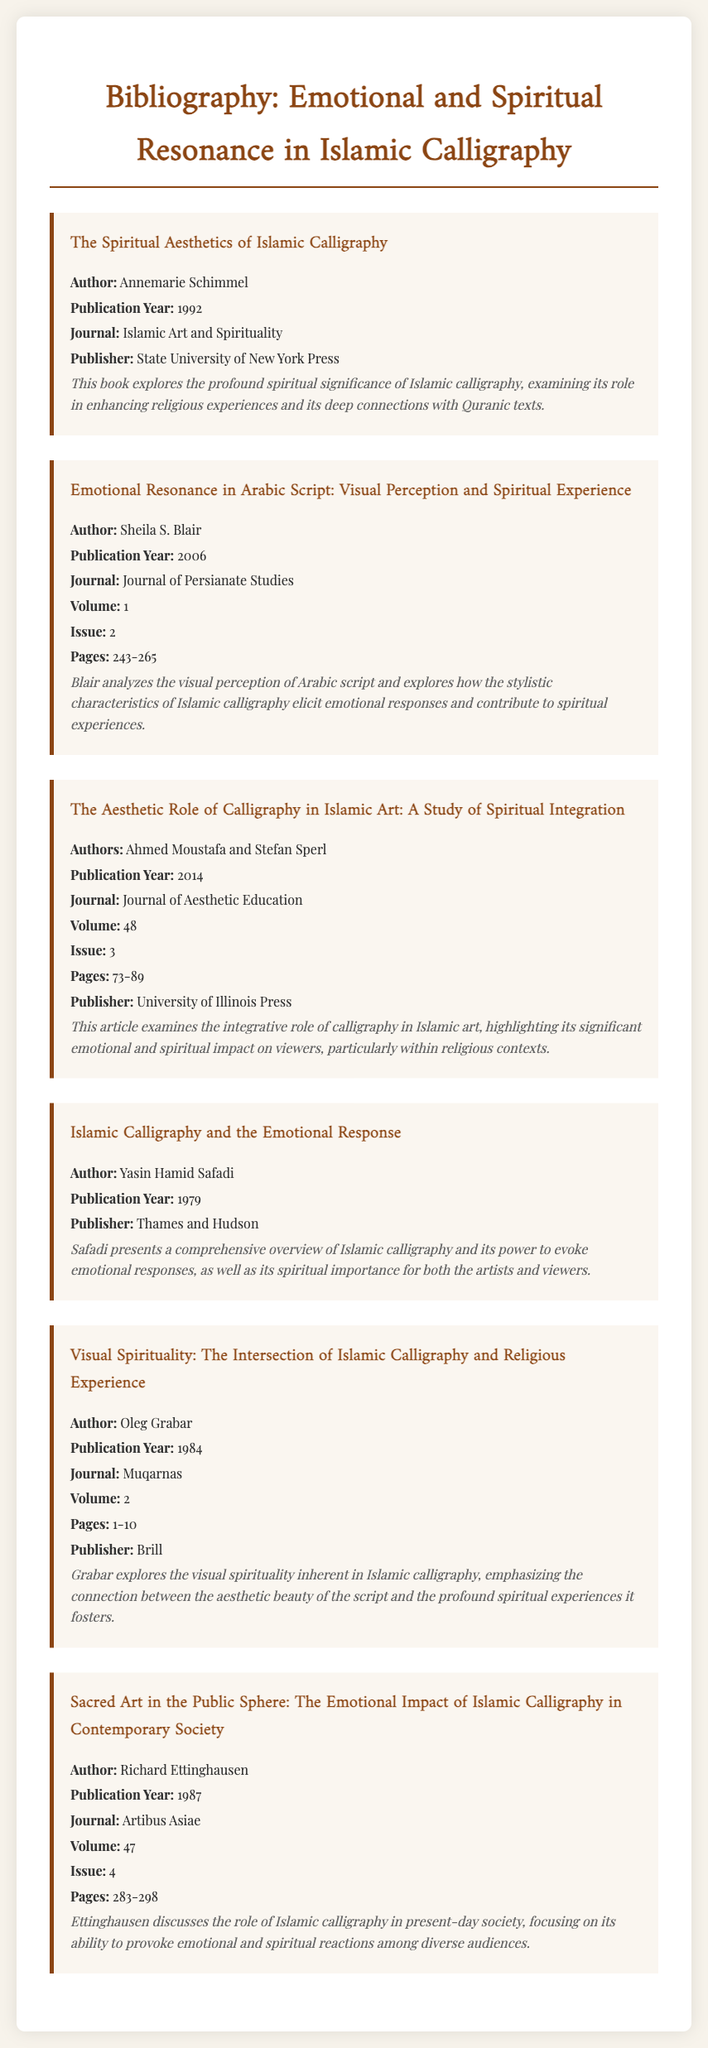What is the title of the first item in the bibliography? The title can be found in the heading of the first item in the document.
Answer: The Spiritual Aesthetics of Islamic Calligraphy Who is the author of the article published in 2006? The author's name is listed right under the title for the article published in that year.
Answer: Sheila S. Blair What is the publication year of the book "Islamic Calligraphy and the Emotional Response"? The publication year is mentioned directly after the author's name in the corresponding item.
Answer: 1979 Which journal published the work by Oleg Grabar? The journal name is specified in the bibliographic entry for Oleg Grabar's work.
Answer: Muqarnas What are the page numbers for the article by Ahmed Moustafa and Stefan Sperl? The page range is listed in the information for their publication in the document.
Answer: 73-89 Name one theme explored by Richard Ettinghausen in his work. The themes he discusses can be inferred from the summary of his entry.
Answer: Emotional and spiritual reactions How many authors contributed to the article titled "The Aesthetic Role of Calligraphy in Islamic Art"? The number of authors can be found in the author section of the entry.
Answer: Two What publisher released Annemarie Schimmel's book? The publisher's name is stated toward the end of Schimmel's entry.
Answer: State University of New York Press Which volume of the Journal of Aesthetic Education features the article by Ahmed Moustafa and Stefan Sperl? The volume number is presented in their bibliographic entry.
Answer: 48 